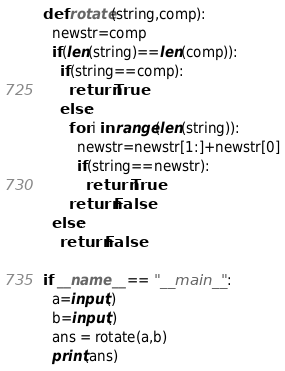<code> <loc_0><loc_0><loc_500><loc_500><_Python_>def rotate(string,comp):
  newstr=comp
  if(len(string)==len(comp)):
    if(string==comp):
      return True
    else:
      for i in range(len(string)):
        newstr=newstr[1:]+newstr[0]
        if(string==newstr):
          return True
      return False
  else:
    return False

if __name__ == "__main__":
  a=input()
  b=input()
  ans = rotate(a,b)
  print(ans)

</code> 